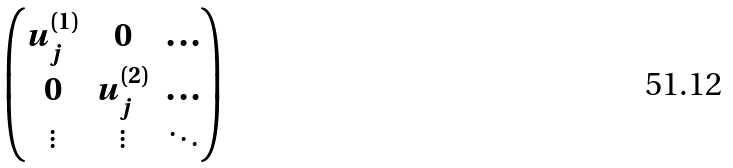<formula> <loc_0><loc_0><loc_500><loc_500>\begin{pmatrix} u _ { j } ^ { ( 1 ) } & 0 & \dots \\ 0 & u _ { j } ^ { ( 2 ) } & \dots \\ \vdots & \vdots & \ddots \end{pmatrix}</formula> 